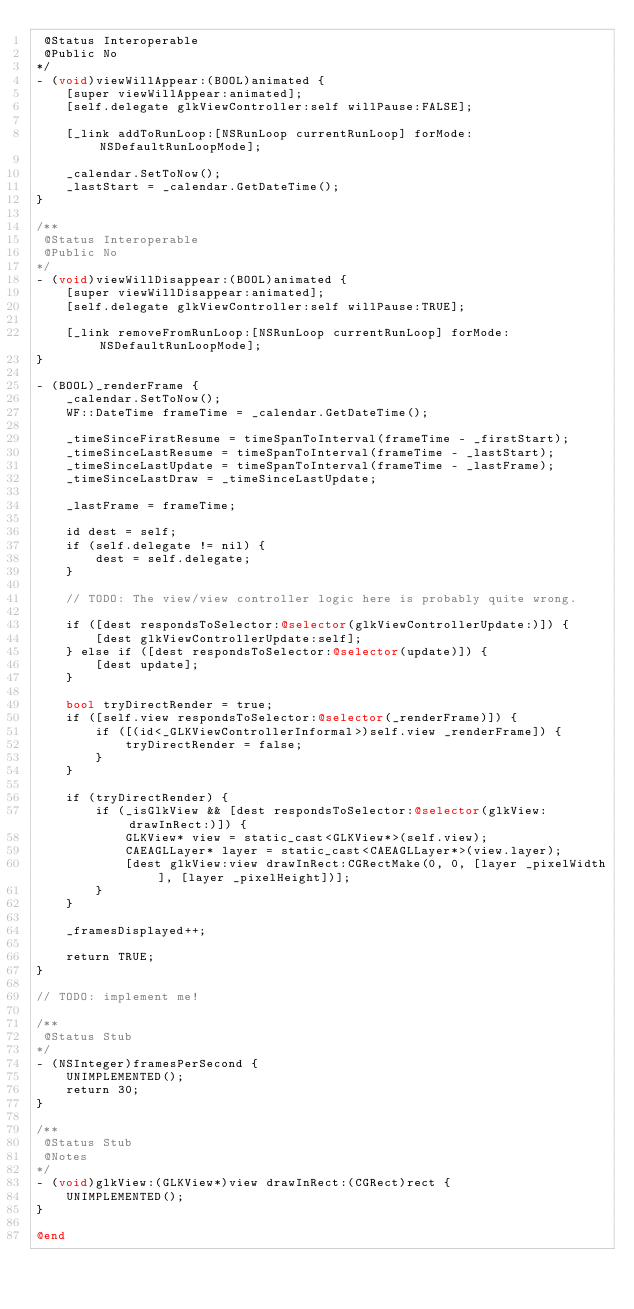<code> <loc_0><loc_0><loc_500><loc_500><_ObjectiveC_> @Status Interoperable
 @Public No
*/
- (void)viewWillAppear:(BOOL)animated {
    [super viewWillAppear:animated];
    [self.delegate glkViewController:self willPause:FALSE];

    [_link addToRunLoop:[NSRunLoop currentRunLoop] forMode:NSDefaultRunLoopMode];

    _calendar.SetToNow();
    _lastStart = _calendar.GetDateTime();
}

/**
 @Status Interoperable
 @Public No
*/
- (void)viewWillDisappear:(BOOL)animated {
    [super viewWillDisappear:animated];
    [self.delegate glkViewController:self willPause:TRUE];

    [_link removeFromRunLoop:[NSRunLoop currentRunLoop] forMode:NSDefaultRunLoopMode];
}

- (BOOL)_renderFrame {
    _calendar.SetToNow();
    WF::DateTime frameTime = _calendar.GetDateTime();

    _timeSinceFirstResume = timeSpanToInterval(frameTime - _firstStart);
    _timeSinceLastResume = timeSpanToInterval(frameTime - _lastStart);
    _timeSinceLastUpdate = timeSpanToInterval(frameTime - _lastFrame);
    _timeSinceLastDraw = _timeSinceLastUpdate;

    _lastFrame = frameTime;

    id dest = self;
    if (self.delegate != nil) {
        dest = self.delegate;
    }

    // TODO: The view/view controller logic here is probably quite wrong.

    if ([dest respondsToSelector:@selector(glkViewControllerUpdate:)]) {
        [dest glkViewControllerUpdate:self];
    } else if ([dest respondsToSelector:@selector(update)]) {
        [dest update];
    }

    bool tryDirectRender = true;
    if ([self.view respondsToSelector:@selector(_renderFrame)]) {
        if ([(id<_GLKViewControllerInformal>)self.view _renderFrame]) {
            tryDirectRender = false;
        }
    }

    if (tryDirectRender) {
        if (_isGlkView && [dest respondsToSelector:@selector(glkView:drawInRect:)]) {
            GLKView* view = static_cast<GLKView*>(self.view);
            CAEAGLLayer* layer = static_cast<CAEAGLLayer*>(view.layer);
            [dest glkView:view drawInRect:CGRectMake(0, 0, [layer _pixelWidth], [layer _pixelHeight])];
        }
    }

    _framesDisplayed++;

    return TRUE;
}

// TODO: implement me!

/**
 @Status Stub
*/
- (NSInteger)framesPerSecond {
    UNIMPLEMENTED();
    return 30;
}

/**
 @Status Stub
 @Notes
*/
- (void)glkView:(GLKView*)view drawInRect:(CGRect)rect {
    UNIMPLEMENTED();
}

@end
</code> 